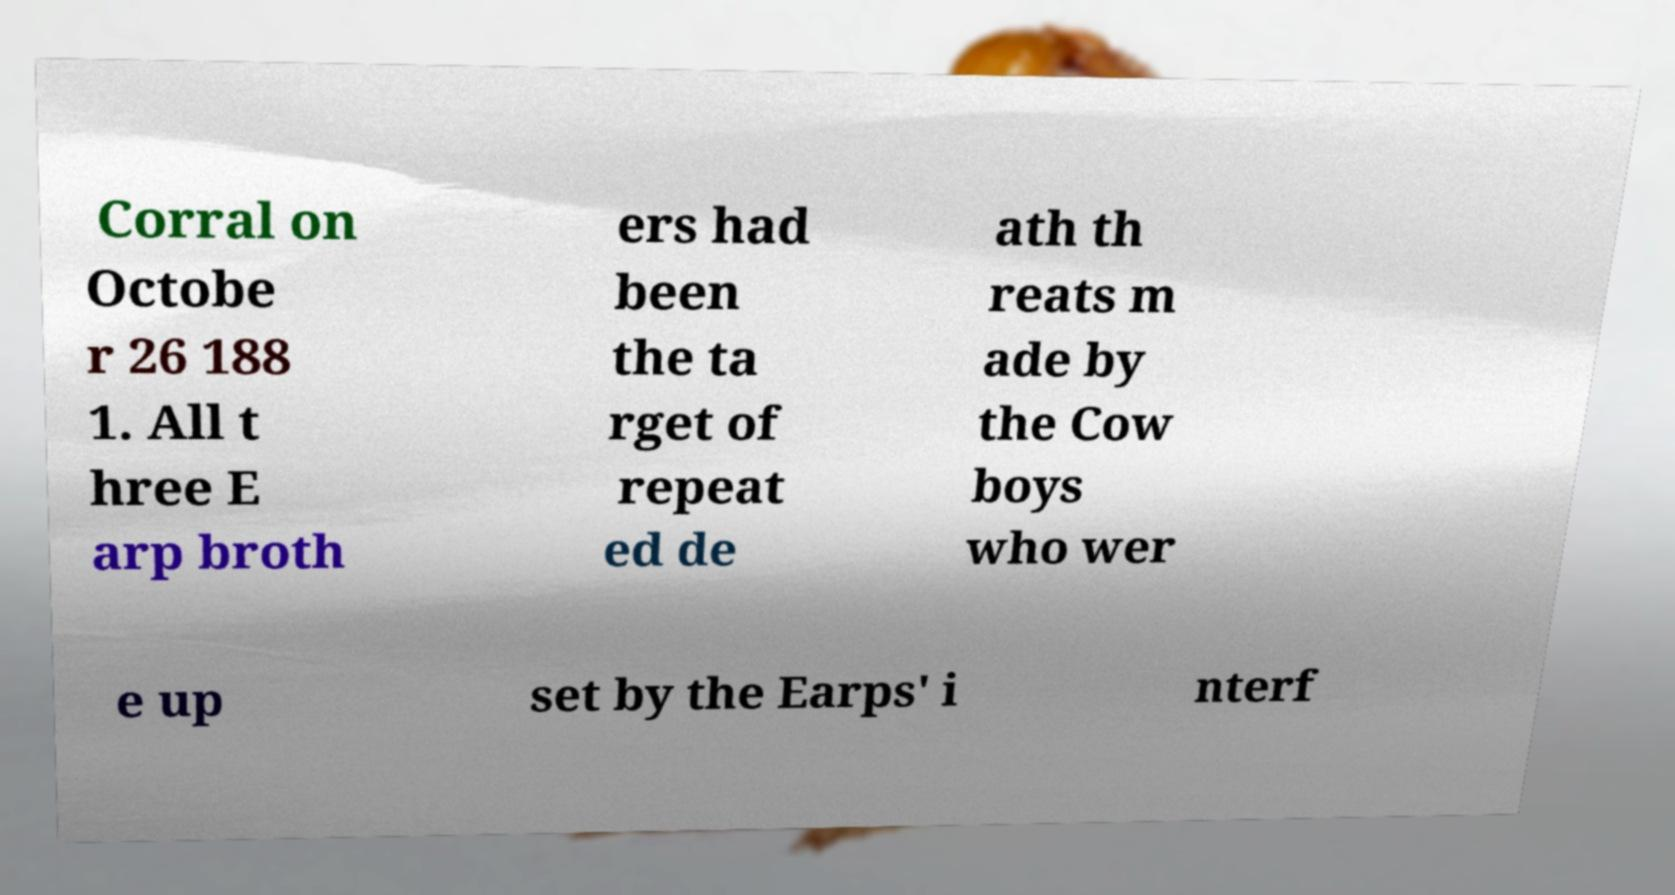What messages or text are displayed in this image? I need them in a readable, typed format. Corral on Octobe r 26 188 1. All t hree E arp broth ers had been the ta rget of repeat ed de ath th reats m ade by the Cow boys who wer e up set by the Earps' i nterf 